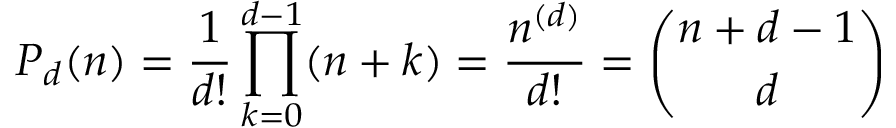Convert formula to latex. <formula><loc_0><loc_0><loc_500><loc_500>P _ { d } ( n ) = { \frac { 1 } { d ! } } \prod _ { k = 0 } ^ { d - 1 } ( n + k ) = { \frac { n ^ { ( d ) } } { d ! } } = { \binom { n + d - 1 } { d } }</formula> 